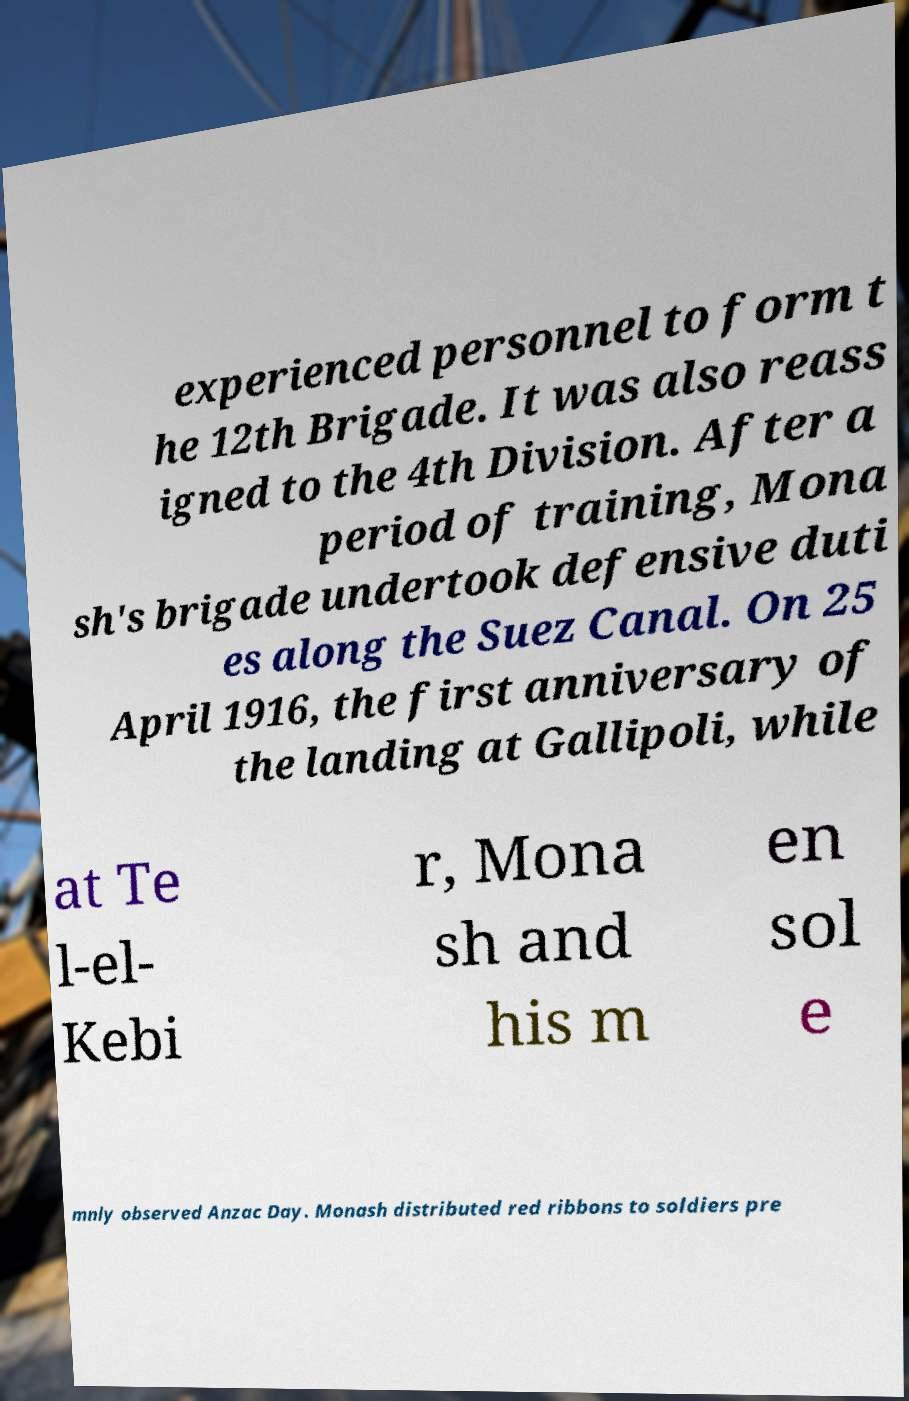Could you assist in decoding the text presented in this image and type it out clearly? experienced personnel to form t he 12th Brigade. It was also reass igned to the 4th Division. After a period of training, Mona sh's brigade undertook defensive duti es along the Suez Canal. On 25 April 1916, the first anniversary of the landing at Gallipoli, while at Te l-el- Kebi r, Mona sh and his m en sol e mnly observed Anzac Day. Monash distributed red ribbons to soldiers pre 